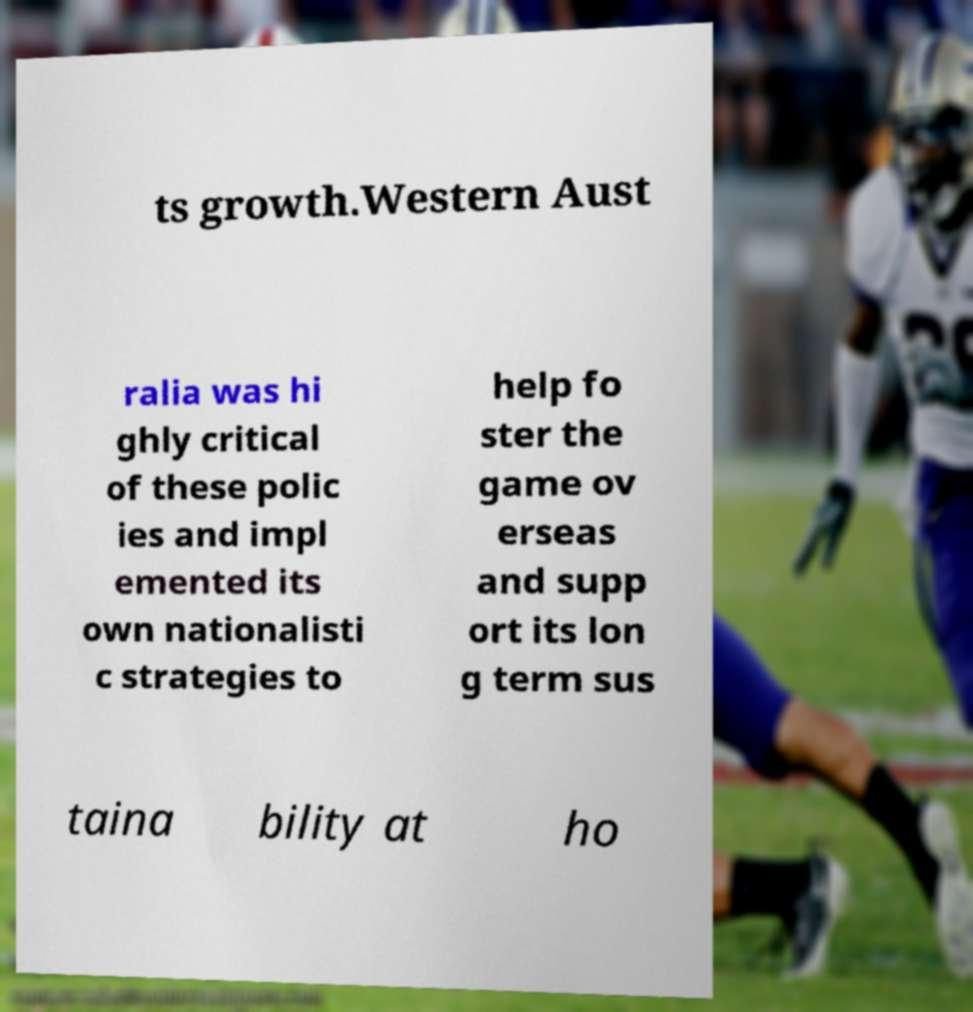What messages or text are displayed in this image? I need them in a readable, typed format. ts growth.Western Aust ralia was hi ghly critical of these polic ies and impl emented its own nationalisti c strategies to help fo ster the game ov erseas and supp ort its lon g term sus taina bility at ho 